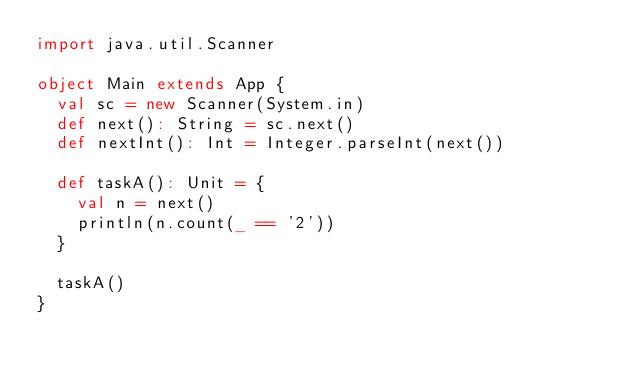Convert code to text. <code><loc_0><loc_0><loc_500><loc_500><_Scala_>import java.util.Scanner

object Main extends App {
  val sc = new Scanner(System.in)
  def next(): String = sc.next()
  def nextInt(): Int = Integer.parseInt(next())

  def taskA(): Unit = {
    val n = next()
    println(n.count(_ == '2'))
  }

  taskA()
}
</code> 